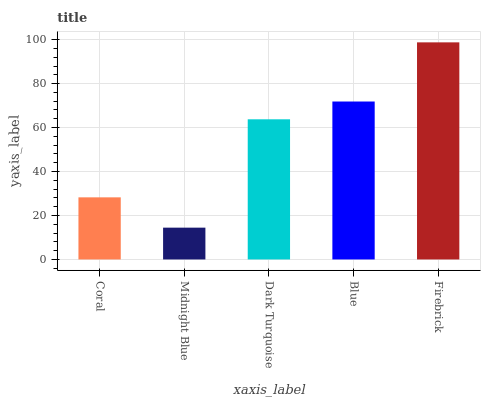Is Midnight Blue the minimum?
Answer yes or no. Yes. Is Firebrick the maximum?
Answer yes or no. Yes. Is Dark Turquoise the minimum?
Answer yes or no. No. Is Dark Turquoise the maximum?
Answer yes or no. No. Is Dark Turquoise greater than Midnight Blue?
Answer yes or no. Yes. Is Midnight Blue less than Dark Turquoise?
Answer yes or no. Yes. Is Midnight Blue greater than Dark Turquoise?
Answer yes or no. No. Is Dark Turquoise less than Midnight Blue?
Answer yes or no. No. Is Dark Turquoise the high median?
Answer yes or no. Yes. Is Dark Turquoise the low median?
Answer yes or no. Yes. Is Midnight Blue the high median?
Answer yes or no. No. Is Firebrick the low median?
Answer yes or no. No. 